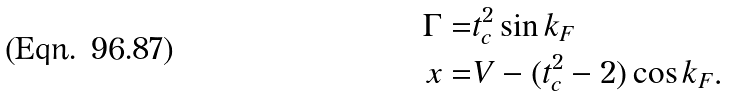<formula> <loc_0><loc_0><loc_500><loc_500>\Gamma = & t _ { c } ^ { 2 } \sin k _ { F } \\ x = & V - ( t _ { c } ^ { 2 } - 2 ) \cos k _ { F } .</formula> 